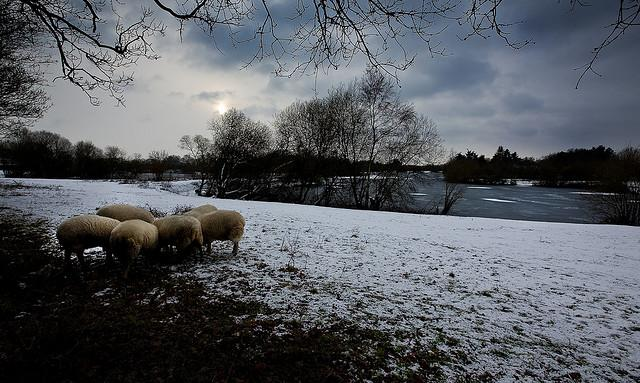These animals are in a formation that is reminiscent of what sport? rugby 